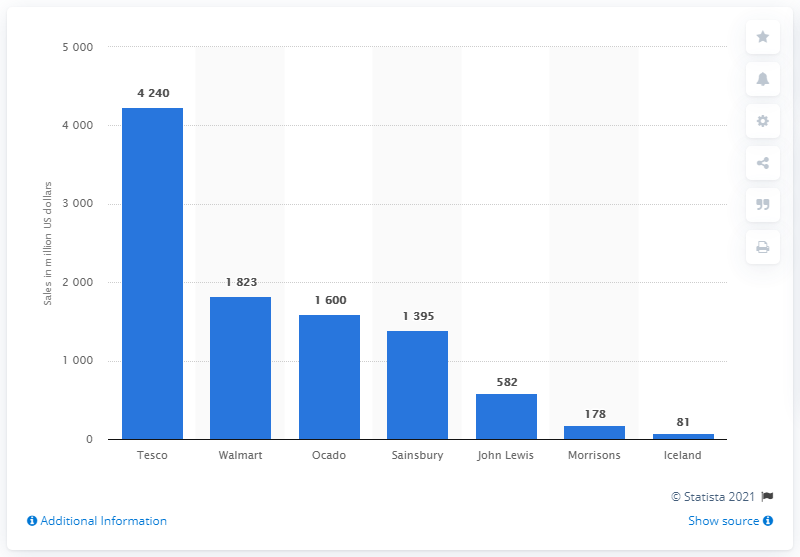Specify some key components in this picture. According to data from 2015, Tesco was the online grocery retailer with the highest sales value of edible goods. In 2015, Walmart was the online grocery retailer with the largest edible grocery sales value. 